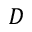<formula> <loc_0><loc_0><loc_500><loc_500>D</formula> 